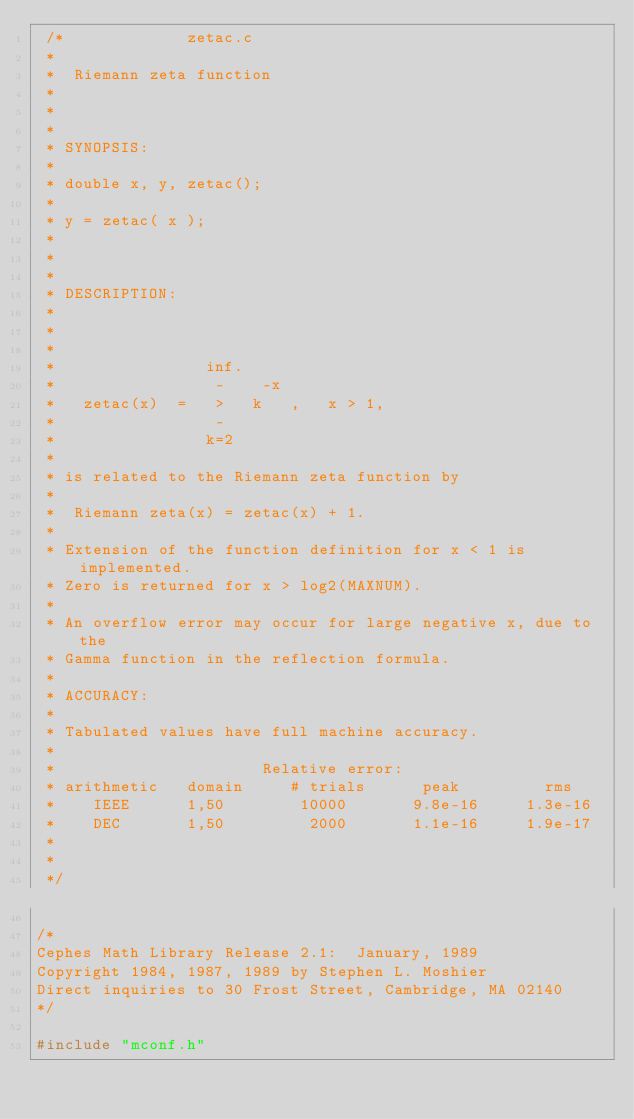<code> <loc_0><loc_0><loc_500><loc_500><_C_> /*							zetac.c
 *
 *	Riemann zeta function
 *
 *
 *
 * SYNOPSIS:
 *
 * double x, y, zetac();
 *
 * y = zetac( x );
 *
 *
 *
 * DESCRIPTION:
 *
 *
 *
 *                inf.
 *                 -    -x
 *   zetac(x)  =   >   k   ,   x > 1,
 *                 -
 *                k=2
 *
 * is related to the Riemann zeta function by
 *
 *	Riemann zeta(x) = zetac(x) + 1.
 *
 * Extension of the function definition for x < 1 is implemented.
 * Zero is returned for x > log2(MAXNUM).
 *
 * An overflow error may occur for large negative x, due to the
 * Gamma function in the reflection formula.
 *
 * ACCURACY:
 *
 * Tabulated values have full machine accuracy.
 *
 *                      Relative error:
 * arithmetic   domain     # trials      peak         rms
 *    IEEE      1,50        10000       9.8e-16	    1.3e-16
 *    DEC       1,50         2000       1.1e-16     1.9e-17
 *
 *
 */

/*
Cephes Math Library Release 2.1:  January, 1989
Copyright 1984, 1987, 1989 by Stephen L. Moshier
Direct inquiries to 30 Frost Street, Cambridge, MA 02140
*/

#include "mconf.h"
</code> 